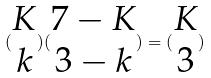Convert formula to latex. <formula><loc_0><loc_0><loc_500><loc_500>( \begin{matrix} K \\ k \end{matrix} ) ( \begin{matrix} 7 - K \\ 3 - k \end{matrix} ) = ( \begin{matrix} K \\ 3 \end{matrix} )</formula> 